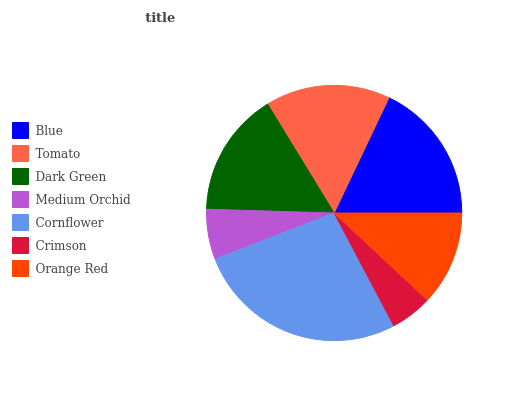Is Crimson the minimum?
Answer yes or no. Yes. Is Cornflower the maximum?
Answer yes or no. Yes. Is Tomato the minimum?
Answer yes or no. No. Is Tomato the maximum?
Answer yes or no. No. Is Blue greater than Tomato?
Answer yes or no. Yes. Is Tomato less than Blue?
Answer yes or no. Yes. Is Tomato greater than Blue?
Answer yes or no. No. Is Blue less than Tomato?
Answer yes or no. No. Is Tomato the high median?
Answer yes or no. Yes. Is Tomato the low median?
Answer yes or no. Yes. Is Orange Red the high median?
Answer yes or no. No. Is Orange Red the low median?
Answer yes or no. No. 